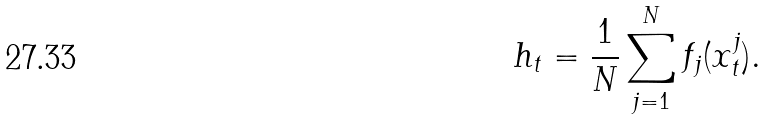<formula> <loc_0><loc_0><loc_500><loc_500>h _ { t } = \frac { 1 } { N } \sum _ { j = 1 } ^ { N } f _ { j } ( x _ { t } ^ { j } ) .</formula> 